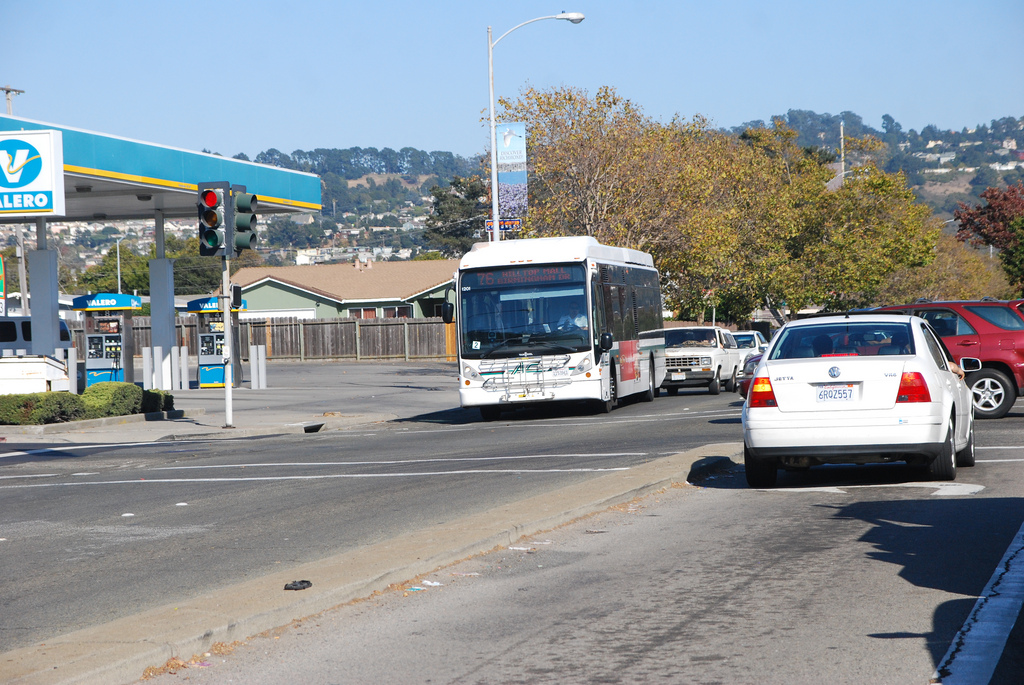Is the car to the right or to the left of the bus? The car is driving to the right of the white bus, which is in a separate lane to the car's left. 